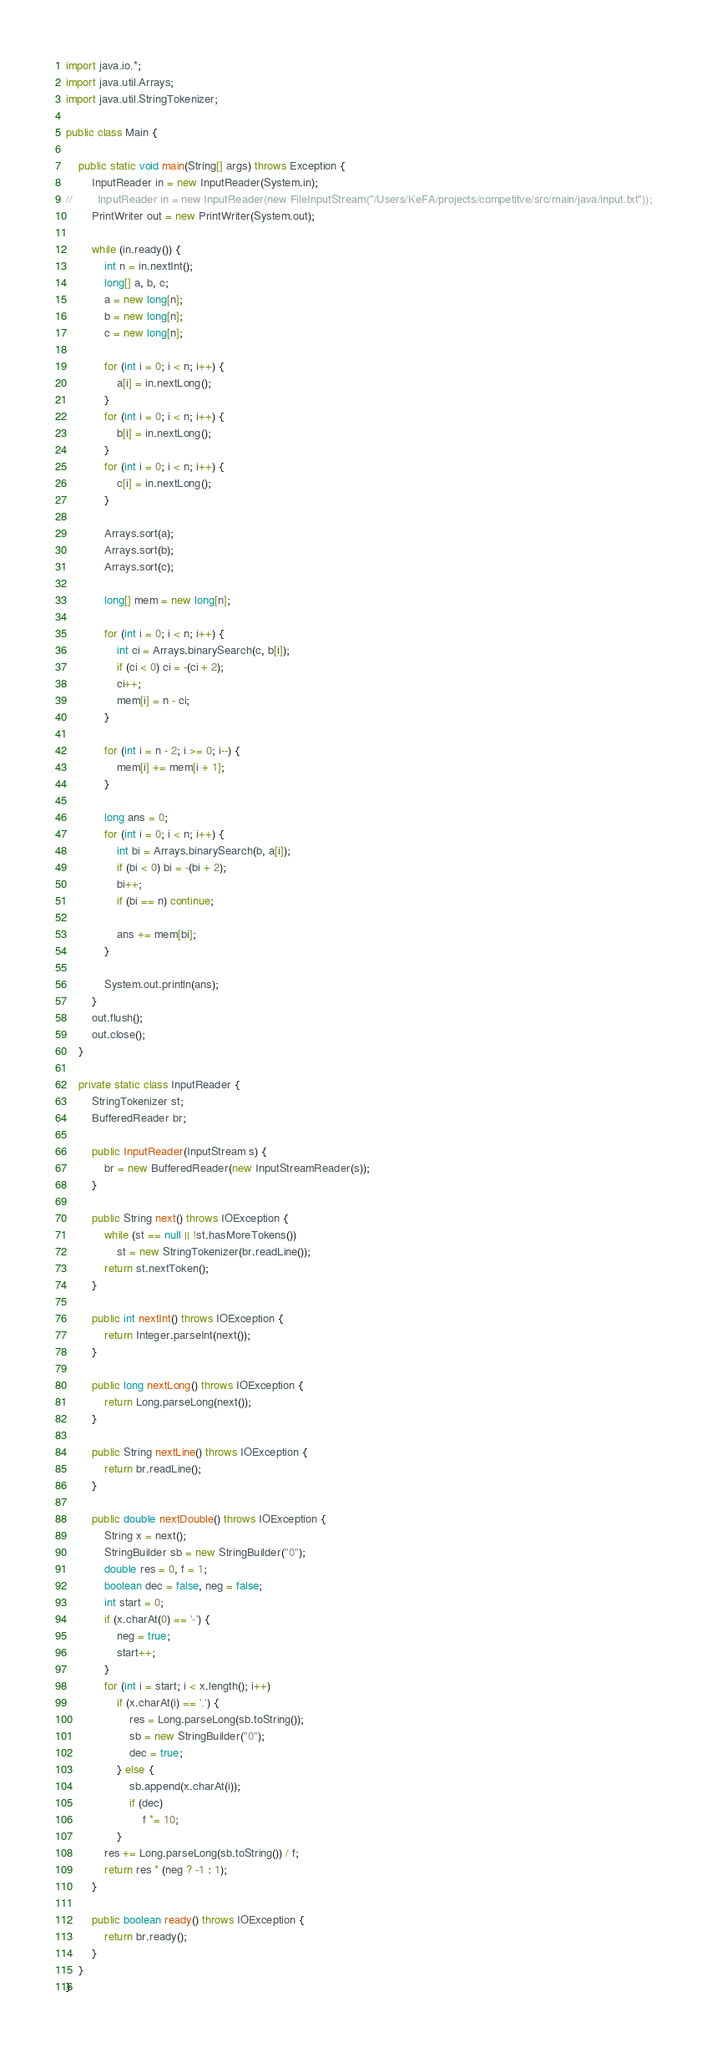Convert code to text. <code><loc_0><loc_0><loc_500><loc_500><_Java_>import java.io.*;
import java.util.Arrays;
import java.util.StringTokenizer;

public class Main {

    public static void main(String[] args) throws Exception {
        InputReader in = new InputReader(System.in);
//        InputReader in = new InputReader(new FileInputStream("/Users/KeFA/projects/competitve/src/main/java/input.txt"));
        PrintWriter out = new PrintWriter(System.out);

        while (in.ready()) {
            int n = in.nextInt();
            long[] a, b, c;
            a = new long[n];
            b = new long[n];
            c = new long[n];

            for (int i = 0; i < n; i++) {
                a[i] = in.nextLong();
            }
            for (int i = 0; i < n; i++) {
                b[i] = in.nextLong();
            }
            for (int i = 0; i < n; i++) {
                c[i] = in.nextLong();
            }

            Arrays.sort(a);
            Arrays.sort(b);
            Arrays.sort(c);

            long[] mem = new long[n];

            for (int i = 0; i < n; i++) {
                int ci = Arrays.binarySearch(c, b[i]);
                if (ci < 0) ci = -(ci + 2);
                ci++;
                mem[i] = n - ci;
            }

            for (int i = n - 2; i >= 0; i--) {
                mem[i] += mem[i + 1];
            }

            long ans = 0;
            for (int i = 0; i < n; i++) {
                int bi = Arrays.binarySearch(b, a[i]);
                if (bi < 0) bi = -(bi + 2);
                bi++;
                if (bi == n) continue;

                ans += mem[bi];
            }

            System.out.println(ans);
        }
        out.flush();
        out.close();
    }

    private static class InputReader {
        StringTokenizer st;
        BufferedReader br;

        public InputReader(InputStream s) {
            br = new BufferedReader(new InputStreamReader(s));
        }

        public String next() throws IOException {
            while (st == null || !st.hasMoreTokens())
                st = new StringTokenizer(br.readLine());
            return st.nextToken();
        }

        public int nextInt() throws IOException {
            return Integer.parseInt(next());
        }

        public long nextLong() throws IOException {
            return Long.parseLong(next());
        }

        public String nextLine() throws IOException {
            return br.readLine();
        }

        public double nextDouble() throws IOException {
            String x = next();
            StringBuilder sb = new StringBuilder("0");
            double res = 0, f = 1;
            boolean dec = false, neg = false;
            int start = 0;
            if (x.charAt(0) == '-') {
                neg = true;
                start++;
            }
            for (int i = start; i < x.length(); i++)
                if (x.charAt(i) == '.') {
                    res = Long.parseLong(sb.toString());
                    sb = new StringBuilder("0");
                    dec = true;
                } else {
                    sb.append(x.charAt(i));
                    if (dec)
                        f *= 10;
                }
            res += Long.parseLong(sb.toString()) / f;
            return res * (neg ? -1 : 1);
        }

        public boolean ready() throws IOException {
            return br.ready();
        }
    }
}
</code> 